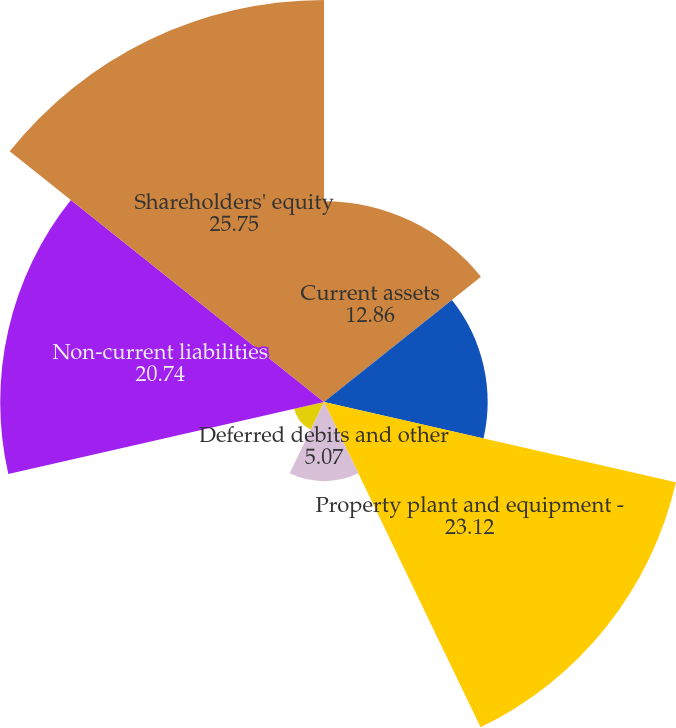Convert chart to OTSL. <chart><loc_0><loc_0><loc_500><loc_500><pie_chart><fcel>Current assets<fcel>Other property and investments<fcel>Property plant and equipment -<fcel>Deferred debits and other<fcel>Current liabilities<fcel>Non-current liabilities<fcel>Shareholders' equity<nl><fcel>12.86%<fcel>10.48%<fcel>23.12%<fcel>5.07%<fcel>1.96%<fcel>20.74%<fcel>25.75%<nl></chart> 